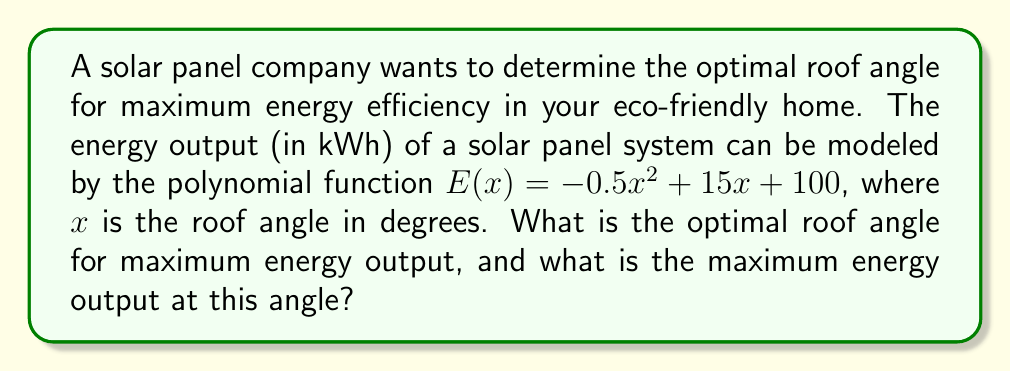Give your solution to this math problem. To find the optimal roof angle for maximum energy output, we need to follow these steps:

1) The function $E(x) = -0.5x^2 + 15x + 100$ is a quadratic function, which forms a parabola when graphed. The maximum point of this parabola will give us the optimal angle and maximum energy output.

2) To find the maximum point, we need to find the vertex of the parabola. For a quadratic function in the form $f(x) = ax^2 + bx + c$, the x-coordinate of the vertex is given by $x = -\frac{b}{2a}$.

3) In our function, $a = -0.5$ and $b = 15$. Let's substitute these values:

   $x = -\frac{15}{2(-0.5)} = -\frac{15}{-1} = 15$

4) This means the optimal roof angle is 15 degrees.

5) To find the maximum energy output, we need to substitute this x-value back into our original function:

   $E(15) = -0.5(15)^2 + 15(15) + 100$
          $= -0.5(225) + 225 + 100$
          $= -112.5 + 225 + 100$
          $= 212.5$

Therefore, the maximum energy output is 212.5 kWh.
Answer: Optimal roof angle: 15°; Maximum energy output: 212.5 kWh 